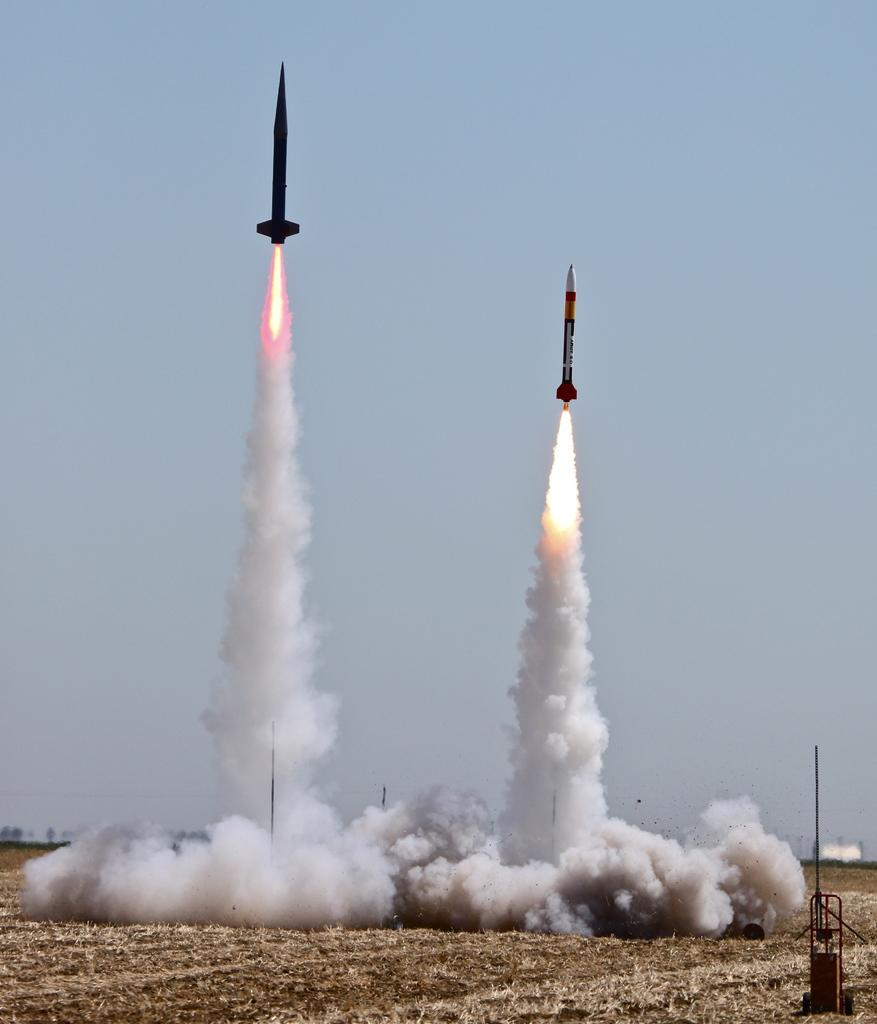What is the main subject of the image? The main subject of the image is two rockets. What are the rockets doing in the image? The rockets are flying in the air. What can be seen under the rockets? There is smoke visible under the rockets. How many deaths can be attributed to the twig in the image? There is no twig present in the image, so it is not possible to attribute any deaths to it. 